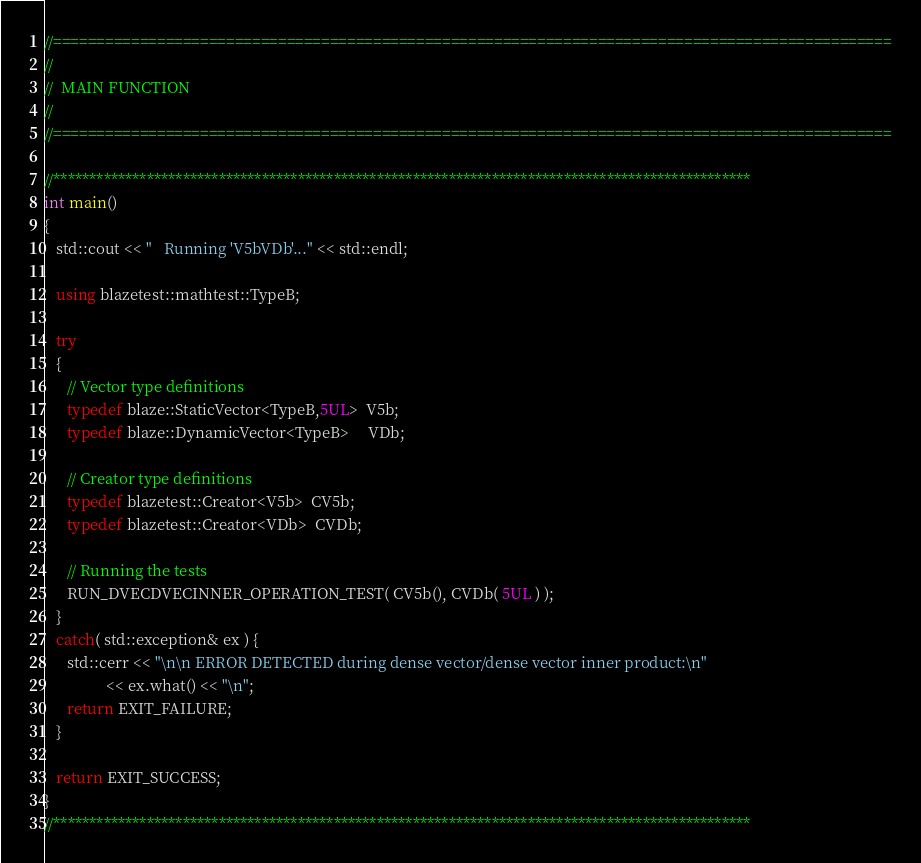<code> <loc_0><loc_0><loc_500><loc_500><_C++_>

//=================================================================================================
//
//  MAIN FUNCTION
//
//=================================================================================================

//*************************************************************************************************
int main()
{
   std::cout << "   Running 'V5bVDb'..." << std::endl;

   using blazetest::mathtest::TypeB;

   try
   {
      // Vector type definitions
      typedef blaze::StaticVector<TypeB,5UL>  V5b;
      typedef blaze::DynamicVector<TypeB>     VDb;

      // Creator type definitions
      typedef blazetest::Creator<V5b>  CV5b;
      typedef blazetest::Creator<VDb>  CVDb;

      // Running the tests
      RUN_DVECDVECINNER_OPERATION_TEST( CV5b(), CVDb( 5UL ) );
   }
   catch( std::exception& ex ) {
      std::cerr << "\n\n ERROR DETECTED during dense vector/dense vector inner product:\n"
                << ex.what() << "\n";
      return EXIT_FAILURE;
   }

   return EXIT_SUCCESS;
}
//*************************************************************************************************
</code> 